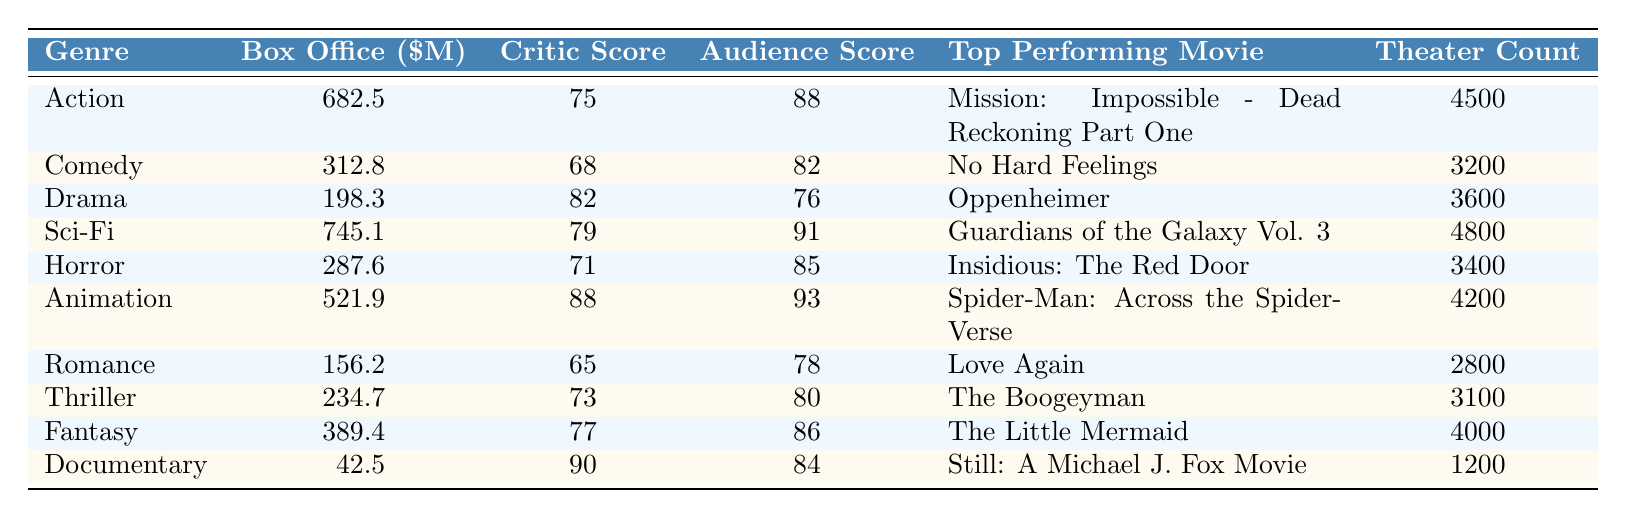What is the total box office revenue for the Action genre? The total box office revenue for the Action genre is provided directly in the table. It shows 682.5 million dollars for that genre.
Answer: 682.5 million dollars Which movie had the highest box office revenue in the Sci-Fi genre? The top-performing movie in the Sci-Fi genre is listed as "Guardians of the Galaxy Vol. 3."
Answer: Guardians of the Galaxy Vol. 3 What is the average audience score for all genres combined? To find the average audience score, we sum the audience scores from all genres, then divide by the total number of genres. The scores are 88, 82, 76, 91, 85, 93, 78, 80, 86, 84. The total is  84.3 and there are 10 genres, thus average is 84.3 / 10 = 84.3.
Answer: 84.3 Is the critic score for Animation greater than the critic score for Comedy? The critic score for Animation is 88, while for Comedy it is 68. Since 88 > 68, the statement is true.
Answer: Yes How much more did Sci-Fi earn at the box office compared to Drama? The box office revenue for Sci-Fi is 745.1 million dollars, while for Drama it is 198.3 million dollars. So, the difference is 745.1 - 198.3 = 546.8 million dollars.
Answer: 546.8 million dollars Which genre had the lowest total box office revenue? To identify this, we compare the total box office revenues from all genres. Documentary has the lowest with 42.5 million dollars compared to others.
Answer: Documentary What is the ratio of the total box office revenue of Action to that of Horror? The total box office revenue for Action is 682.5 million dollars, and for Horror, it is 287.6 million dollars. The ratio is 682.5 / 287.6 which is approximately 2.37 when simplified.
Answer: Approximately 2.37 Which genre has the highest theater count? The theater count for Sci-Fi is listed as 4800, the highest among all listed genres.
Answer: Sci-Fi What is the total box office revenue for Animation and Fantasy combined? The total box office for Animation is 521.9 million dollars, and for Fantasy, it is 389.4 million dollars. Adding these together gives 521.9 + 389.4 = 911.3 million dollars.
Answer: 911.3 million dollars Is the top-performing movie in Romance also the lowest-grossing movie in the table? The top-performing movie in Romance is "Love Again," and total revenue for this genre is 156.2 million dollars, which is not the lowest; Documentary has the lowest with 42.5 million dollars. Thus, the statement is false.
Answer: No 